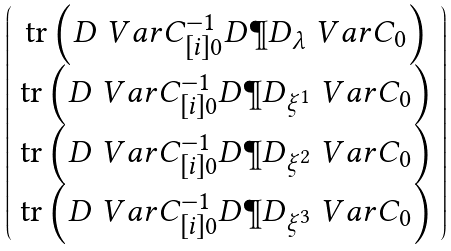Convert formula to latex. <formula><loc_0><loc_0><loc_500><loc_500>\left ( \begin{array} { c } \text {tr} \left ( { D } \ V a r C ^ { - 1 } _ { [ i ] 0 } { D } \P D _ { \lambda } \ V a r C _ { 0 } \right ) \\ \text {tr} \left ( { D } \ V a r C ^ { - 1 } _ { [ i ] 0 } { D } \P D _ { \xi ^ { 1 } } \ V a r C _ { 0 } \right ) \\ \text {tr} \left ( { D } \ V a r C ^ { - 1 } _ { [ i ] 0 } { D } \P D _ { \xi ^ { 2 } } \ V a r C _ { 0 } \right ) \\ \text {tr} \left ( { D } \ V a r C ^ { - 1 } _ { [ i ] 0 } { D } \P D _ { \xi ^ { 3 } } \ V a r C _ { 0 } \right ) \end{array} \right )</formula> 